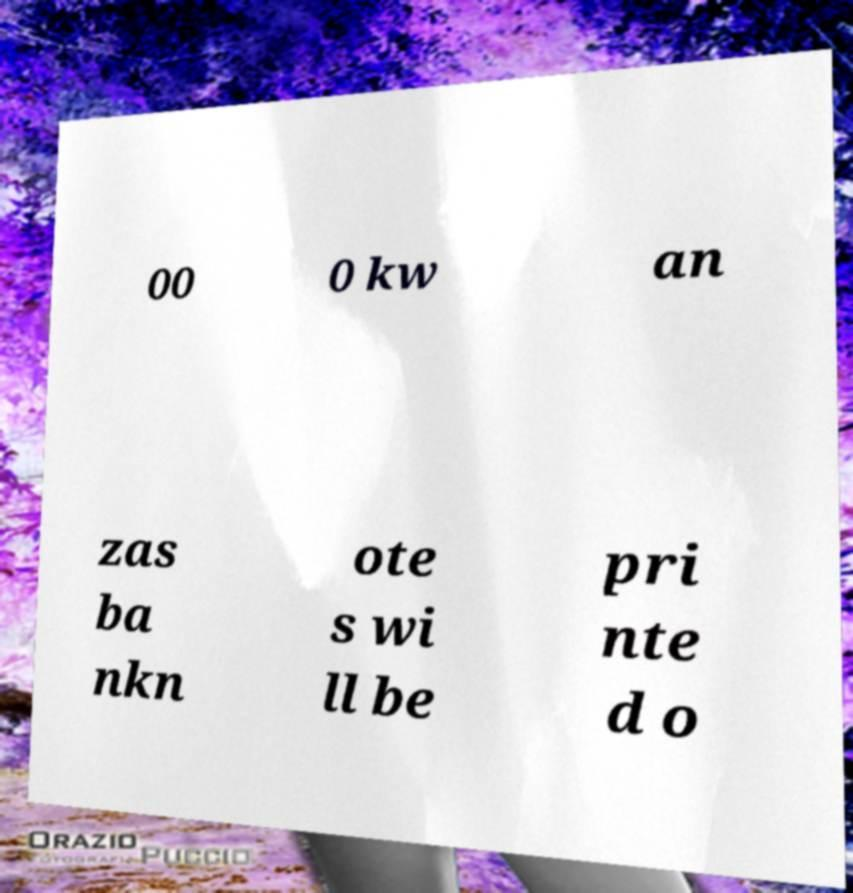Can you accurately transcribe the text from the provided image for me? 00 0 kw an zas ba nkn ote s wi ll be pri nte d o 